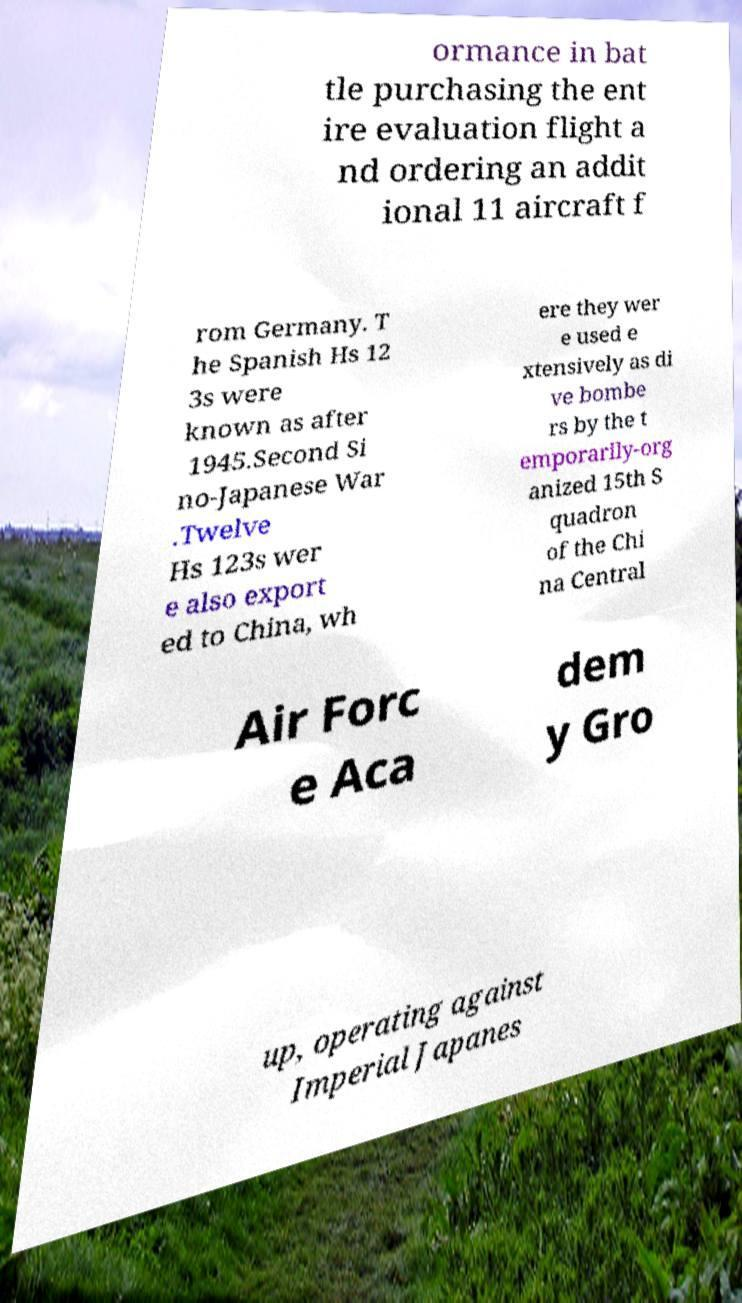I need the written content from this picture converted into text. Can you do that? ormance in bat tle purchasing the ent ire evaluation flight a nd ordering an addit ional 11 aircraft f rom Germany. T he Spanish Hs 12 3s were known as after 1945.Second Si no-Japanese War .Twelve Hs 123s wer e also export ed to China, wh ere they wer e used e xtensively as di ve bombe rs by the t emporarily-org anized 15th S quadron of the Chi na Central Air Forc e Aca dem y Gro up, operating against Imperial Japanes 